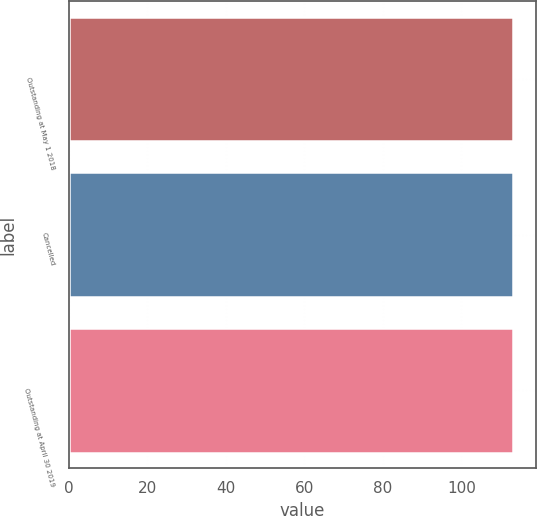Convert chart. <chart><loc_0><loc_0><loc_500><loc_500><bar_chart><fcel>Outstanding at May 1 2018<fcel>Cancelled<fcel>Outstanding at April 30 2019<nl><fcel>113.2<fcel>113.16<fcel>113.24<nl></chart> 